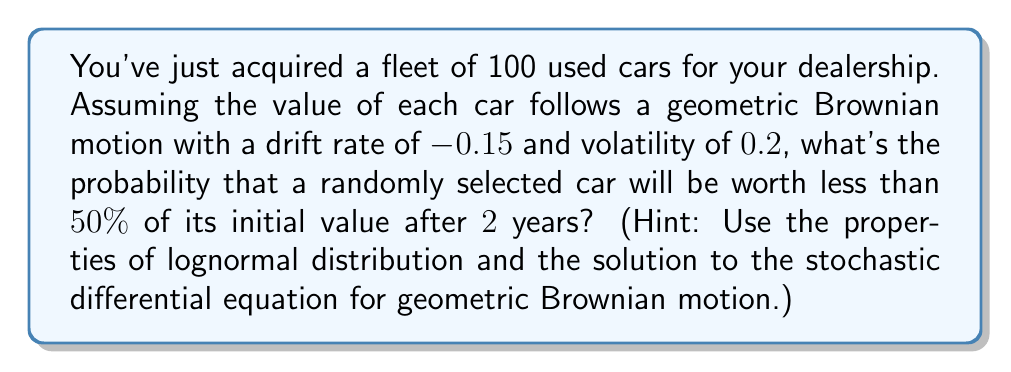Provide a solution to this math problem. Let's approach this step-by-step:

1) The stochastic differential equation for geometric Brownian motion is:

   $$dS_t = \mu S_t dt + \sigma S_t dW_t$$

   where $\mu$ is the drift rate, $\sigma$ is the volatility, and $W_t$ is a Wiener process.

2) The solution to this SDE for the value of the car at time $t$ is:

   $$S_t = S_0 \exp\left(\left(\mu - \frac{\sigma^2}{2}\right)t + \sigma W_t\right)$$

   where $S_0$ is the initial value.

3) We know that $\ln(S_t/S_0)$ follows a normal distribution with mean $(\mu - \frac{\sigma^2}{2})t$ and variance $\sigma^2t$.

4) Given:
   $\mu = -0.15$ (drift rate)
   $\sigma = 0.2$ (volatility)
   $t = 2$ years

5) We want to find $P(S_t < 0.5S_0)$, which is equivalent to $P(\ln(S_t/S_0) < \ln(0.5))$

6) Calculate the mean and variance of $\ln(S_t/S_0)$:
   
   Mean: $m = (-0.15 - \frac{0.2^2}{2}) * 2 = -0.34$
   Variance: $v = 0.2^2 * 2 = 0.08$

7) Standardize the normal distribution:
   
   $$Z = \frac{\ln(0.5) - (-0.34)}{\sqrt{0.08}} = \frac{-0.693 + 0.34}{0.2828} = -1.2483$$

8) The probability is the area under the standard normal curve to the left of Z:

   $$P(S_t < 0.5S_0) = \Phi(-1.2483)$$

   where $\Phi$ is the cumulative distribution function of the standard normal distribution.

9) Using a standard normal table or calculator, we find:

   $$\Phi(-1.2483) \approx 0.1060$$
Answer: 0.1060 or 10.60% 